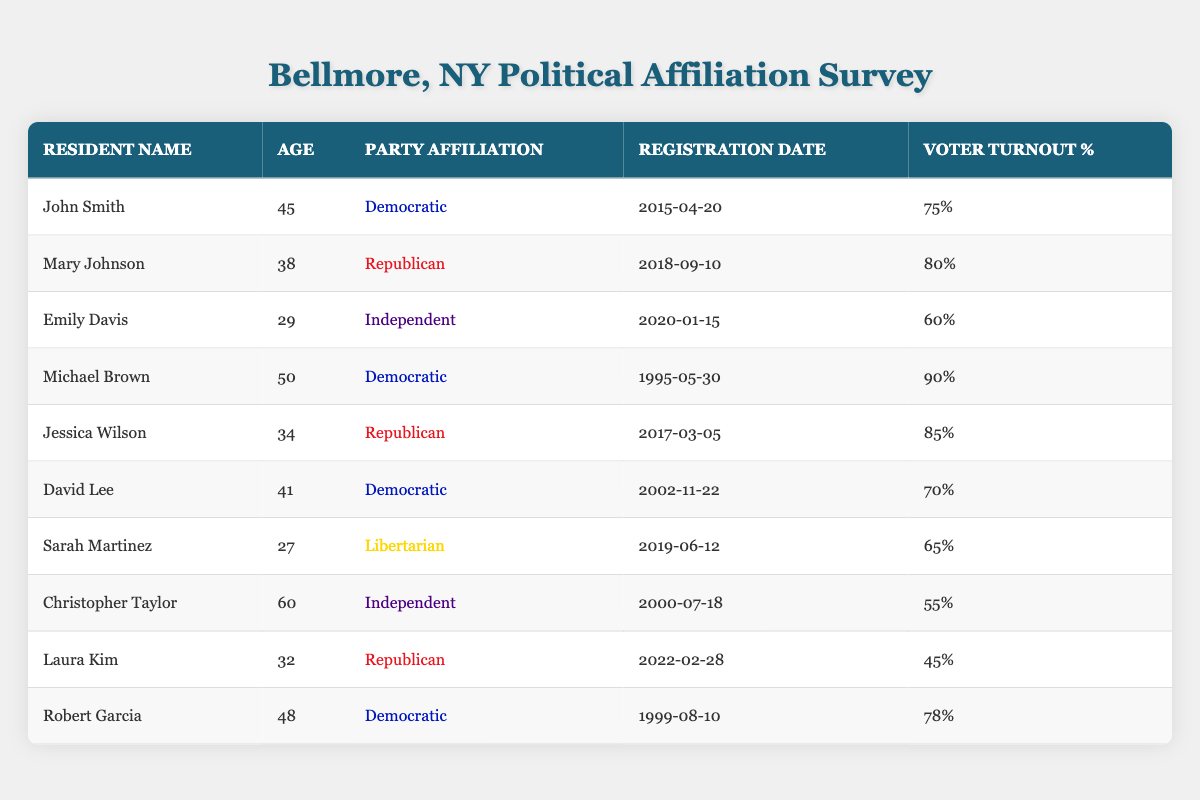What is the party affiliation of John Smith? John Smith is listed in the table with the party affiliation under the "Party Affiliation" column. According to the data, he is affiliated with the Democratic party.
Answer: Democratic How many residents are affiliated with the Republican party? To answer this, we count the number of rows where the party affiliation is Republican. There are three residents: Mary Johnson, Jessica Wilson, and Laura Kim.
Answer: 3 What is the voter turnout percentage for Emily Davis? The voter turnout percentage for each resident is listed in the "Voter Turnout %" column. For Emily Davis, the table shows her voter turnout percentage is 60%.
Answer: 60% Which resident has the highest voter turnout percentage? To determine this, we compare the "Voter Turnout %" values of all residents. The maximum value is 90%, which belongs to Michael Brown.
Answer: Michael Brown Is there any resident who is affiliated with the Libertarian party and has a voter turnout percentage above 60%? We need to check the entry for the resident affiliated with the Libertarian party, which is Sarah Martinez, whose voter turnout percentage is 65%. Since 65% is above 60%, the answer is yes.
Answer: Yes What is the average age of residents affiliated with the Democratic party? We first identify the ages of the Democratic affiliates: John Smith (45), Michael Brown (50), David Lee (41), and Robert Garcia (48). We sum these ages: 45 + 50 + 41 + 48 = 184. There are four Democratic affiliates, so we divide by 4 to find the average: 184 / 4 = 46.
Answer: 46 Who was registered to vote first among residents affiliated with the Republican party? First, we look at the registration dates for the Republican affiliates: Mary Johnson (2018-09-10), Jessica Wilson (2017-03-05), and Laura Kim (2022-02-28). The earliest date is 2017-03-05, belonging to Jessica Wilson.
Answer: Jessica Wilson Are all residents who registered after 2020 affiliated with the Republican party? We find the registration dates after 2020: Emily Davis (2020-01-15), Sarah Martinez (2019-06-12), and Laura Kim (2022-02-28). Emily Davis is Independent and Sarah Martinez is Libertarian, so the statement is false.
Answer: No What is the party affiliation of the oldest resident listed in the table? The oldest resident is Christopher Taylor, who is 60 years old. When checking the party affiliation, we see that he is listed as Independent.
Answer: Independent 